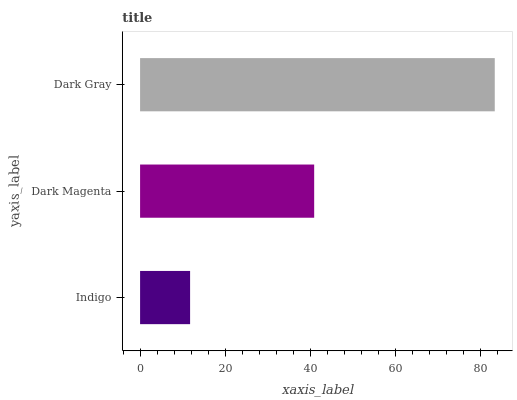Is Indigo the minimum?
Answer yes or no. Yes. Is Dark Gray the maximum?
Answer yes or no. Yes. Is Dark Magenta the minimum?
Answer yes or no. No. Is Dark Magenta the maximum?
Answer yes or no. No. Is Dark Magenta greater than Indigo?
Answer yes or no. Yes. Is Indigo less than Dark Magenta?
Answer yes or no. Yes. Is Indigo greater than Dark Magenta?
Answer yes or no. No. Is Dark Magenta less than Indigo?
Answer yes or no. No. Is Dark Magenta the high median?
Answer yes or no. Yes. Is Dark Magenta the low median?
Answer yes or no. Yes. Is Indigo the high median?
Answer yes or no. No. Is Dark Gray the low median?
Answer yes or no. No. 